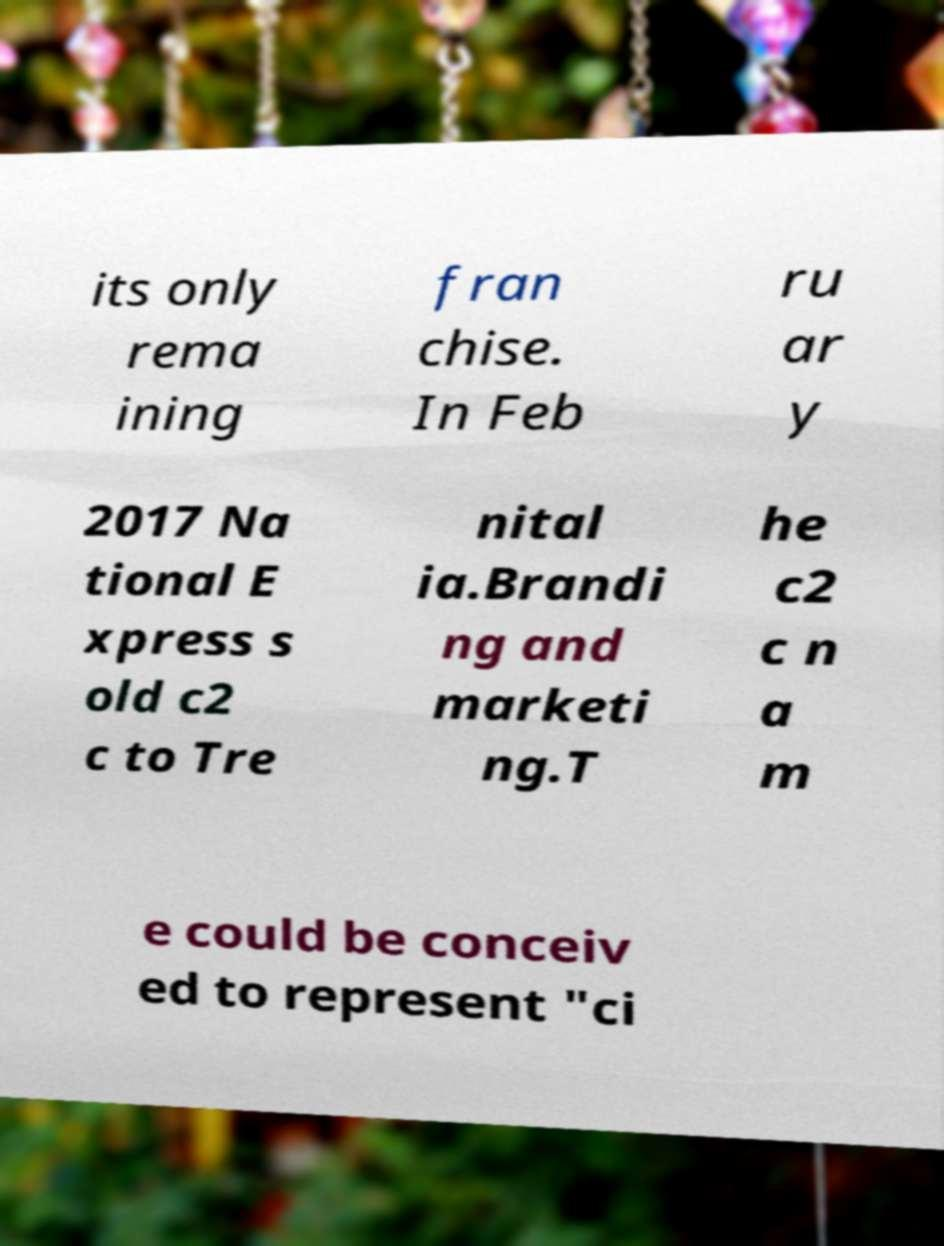There's text embedded in this image that I need extracted. Can you transcribe it verbatim? its only rema ining fran chise. In Feb ru ar y 2017 Na tional E xpress s old c2 c to Tre nital ia.Brandi ng and marketi ng.T he c2 c n a m e could be conceiv ed to represent "ci 